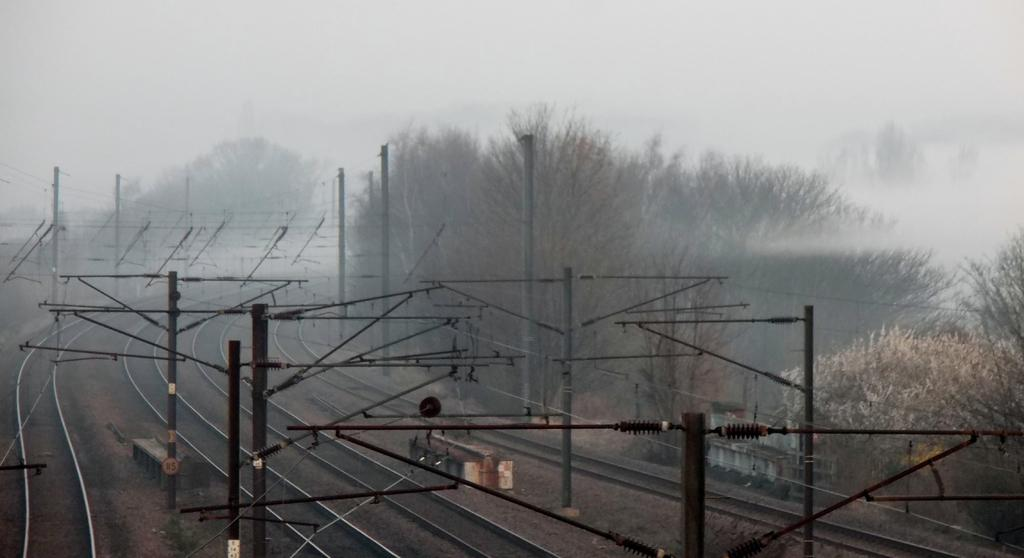What type of transportation infrastructure is visible in the image? There are railway tracks in the image. What is located above the railway tracks? There are metal structures above the railway tracks. What other objects can be seen in the image? There are utility poles in the image. What can be seen in the background of the image? There are trees and the sky visible in the background of the image. What type of tin is used to create the border around the railway tracks in the image? There is no tin or border around the railway tracks in the image; it is a straight line of tracks. 